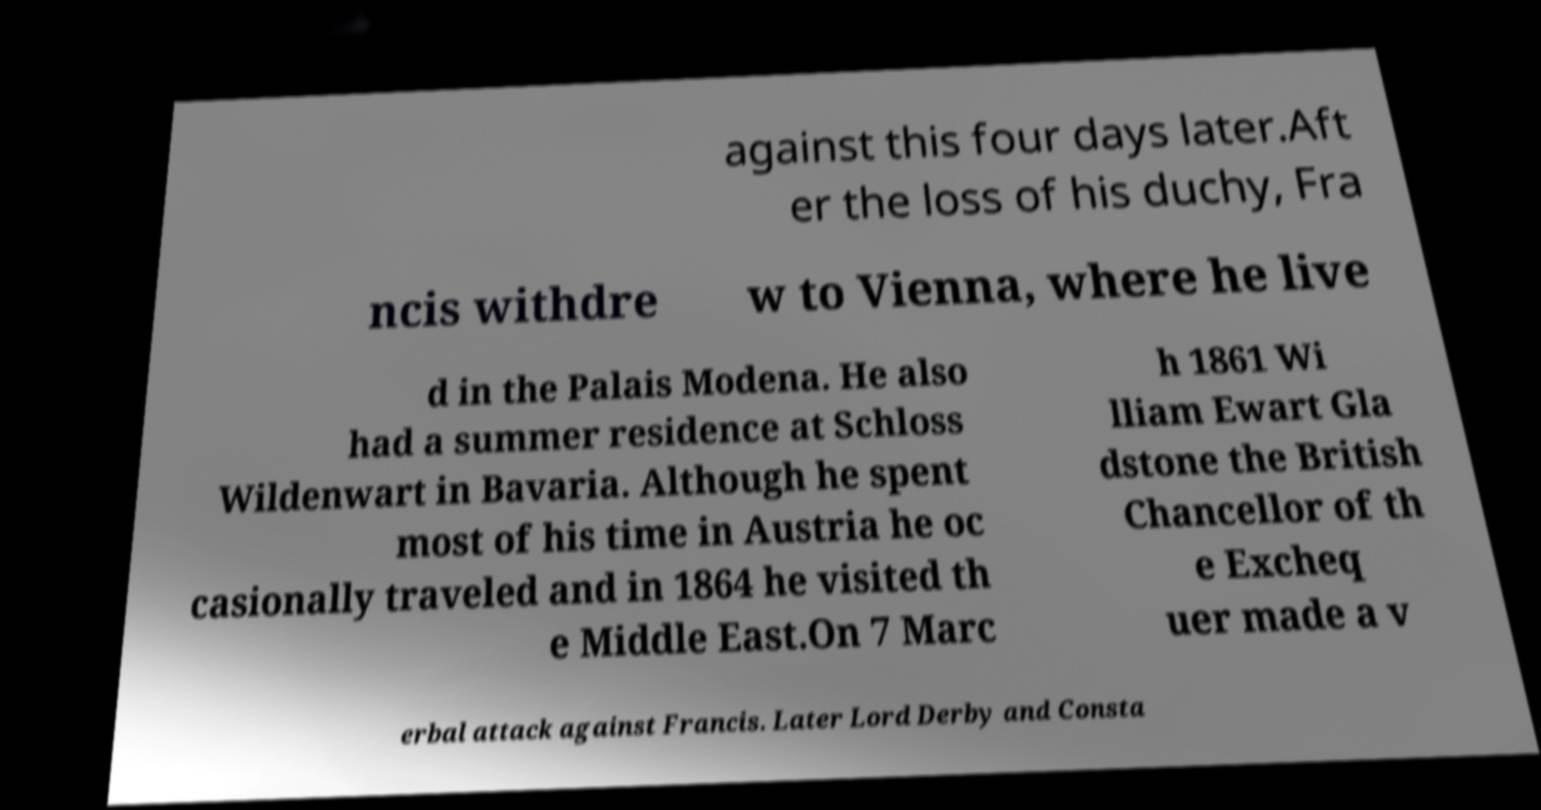What messages or text are displayed in this image? I need them in a readable, typed format. against this four days later.Aft er the loss of his duchy, Fra ncis withdre w to Vienna, where he live d in the Palais Modena. He also had a summer residence at Schloss Wildenwart in Bavaria. Although he spent most of his time in Austria he oc casionally traveled and in 1864 he visited th e Middle East.On 7 Marc h 1861 Wi lliam Ewart Gla dstone the British Chancellor of th e Excheq uer made a v erbal attack against Francis. Later Lord Derby and Consta 